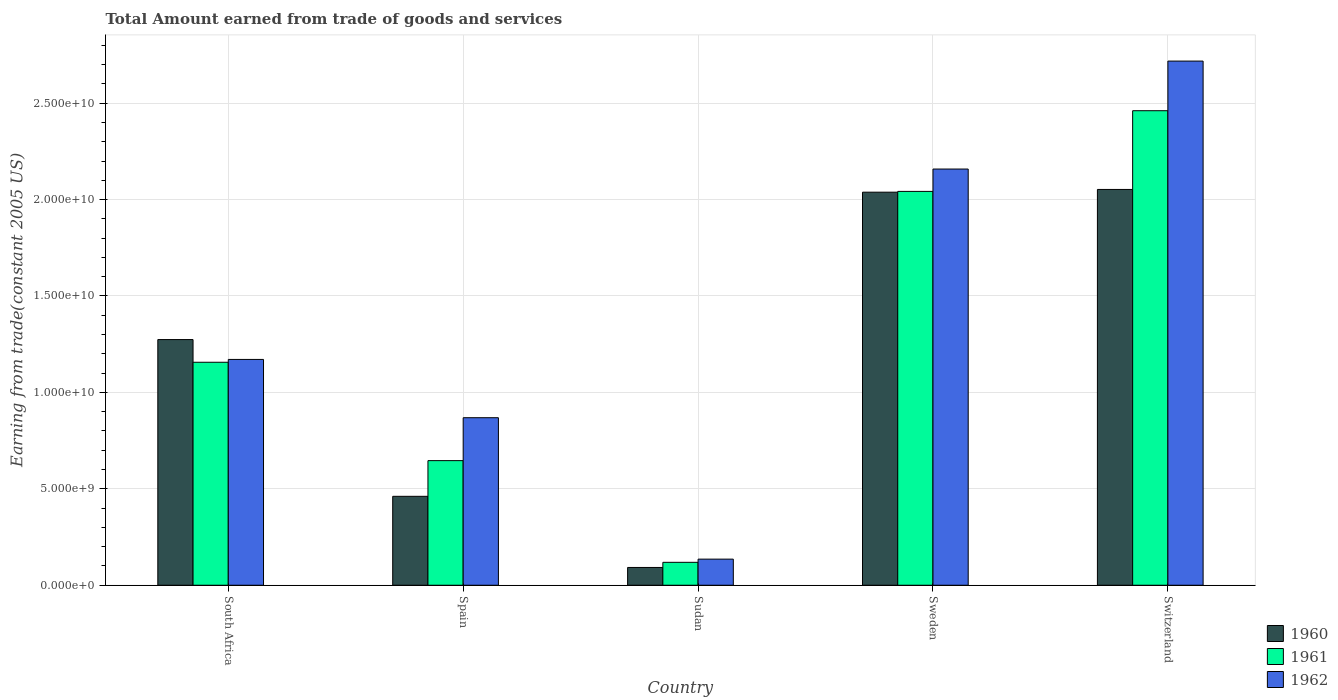How many different coloured bars are there?
Your answer should be very brief. 3. How many bars are there on the 4th tick from the left?
Give a very brief answer. 3. How many bars are there on the 3rd tick from the right?
Give a very brief answer. 3. What is the label of the 4th group of bars from the left?
Ensure brevity in your answer.  Sweden. What is the total amount earned by trading goods and services in 1962 in Sudan?
Your answer should be very brief. 1.35e+09. Across all countries, what is the maximum total amount earned by trading goods and services in 1962?
Offer a terse response. 2.72e+1. Across all countries, what is the minimum total amount earned by trading goods and services in 1961?
Keep it short and to the point. 1.19e+09. In which country was the total amount earned by trading goods and services in 1961 maximum?
Give a very brief answer. Switzerland. In which country was the total amount earned by trading goods and services in 1960 minimum?
Ensure brevity in your answer.  Sudan. What is the total total amount earned by trading goods and services in 1961 in the graph?
Give a very brief answer. 6.42e+1. What is the difference between the total amount earned by trading goods and services in 1960 in Spain and that in Sudan?
Your answer should be very brief. 3.69e+09. What is the difference between the total amount earned by trading goods and services in 1962 in Switzerland and the total amount earned by trading goods and services in 1961 in Spain?
Make the answer very short. 2.07e+1. What is the average total amount earned by trading goods and services in 1961 per country?
Provide a short and direct response. 1.28e+1. What is the difference between the total amount earned by trading goods and services of/in 1960 and total amount earned by trading goods and services of/in 1962 in Sudan?
Your response must be concise. -4.31e+08. What is the ratio of the total amount earned by trading goods and services in 1961 in Spain to that in Sweden?
Your answer should be very brief. 0.32. Is the total amount earned by trading goods and services in 1960 in South Africa less than that in Sweden?
Your response must be concise. Yes. What is the difference between the highest and the second highest total amount earned by trading goods and services in 1962?
Ensure brevity in your answer.  -5.60e+09. What is the difference between the highest and the lowest total amount earned by trading goods and services in 1961?
Your answer should be compact. 2.34e+1. In how many countries, is the total amount earned by trading goods and services in 1961 greater than the average total amount earned by trading goods and services in 1961 taken over all countries?
Ensure brevity in your answer.  2. What does the 2nd bar from the left in Spain represents?
Make the answer very short. 1961. Are all the bars in the graph horizontal?
Provide a short and direct response. No. How many legend labels are there?
Ensure brevity in your answer.  3. How are the legend labels stacked?
Offer a very short reply. Vertical. What is the title of the graph?
Provide a short and direct response. Total Amount earned from trade of goods and services. Does "1990" appear as one of the legend labels in the graph?
Give a very brief answer. No. What is the label or title of the Y-axis?
Provide a succinct answer. Earning from trade(constant 2005 US). What is the Earning from trade(constant 2005 US) in 1960 in South Africa?
Provide a short and direct response. 1.27e+1. What is the Earning from trade(constant 2005 US) in 1961 in South Africa?
Ensure brevity in your answer.  1.16e+1. What is the Earning from trade(constant 2005 US) in 1962 in South Africa?
Offer a very short reply. 1.17e+1. What is the Earning from trade(constant 2005 US) in 1960 in Spain?
Your response must be concise. 4.61e+09. What is the Earning from trade(constant 2005 US) in 1961 in Spain?
Make the answer very short. 6.46e+09. What is the Earning from trade(constant 2005 US) in 1962 in Spain?
Your answer should be very brief. 8.69e+09. What is the Earning from trade(constant 2005 US) of 1960 in Sudan?
Your answer should be very brief. 9.22e+08. What is the Earning from trade(constant 2005 US) of 1961 in Sudan?
Provide a succinct answer. 1.19e+09. What is the Earning from trade(constant 2005 US) of 1962 in Sudan?
Make the answer very short. 1.35e+09. What is the Earning from trade(constant 2005 US) in 1960 in Sweden?
Make the answer very short. 2.04e+1. What is the Earning from trade(constant 2005 US) in 1961 in Sweden?
Provide a succinct answer. 2.04e+1. What is the Earning from trade(constant 2005 US) in 1962 in Sweden?
Ensure brevity in your answer.  2.16e+1. What is the Earning from trade(constant 2005 US) in 1960 in Switzerland?
Your response must be concise. 2.05e+1. What is the Earning from trade(constant 2005 US) in 1961 in Switzerland?
Provide a short and direct response. 2.46e+1. What is the Earning from trade(constant 2005 US) of 1962 in Switzerland?
Provide a succinct answer. 2.72e+1. Across all countries, what is the maximum Earning from trade(constant 2005 US) of 1960?
Ensure brevity in your answer.  2.05e+1. Across all countries, what is the maximum Earning from trade(constant 2005 US) of 1961?
Offer a very short reply. 2.46e+1. Across all countries, what is the maximum Earning from trade(constant 2005 US) of 1962?
Your answer should be very brief. 2.72e+1. Across all countries, what is the minimum Earning from trade(constant 2005 US) of 1960?
Ensure brevity in your answer.  9.22e+08. Across all countries, what is the minimum Earning from trade(constant 2005 US) in 1961?
Provide a succinct answer. 1.19e+09. Across all countries, what is the minimum Earning from trade(constant 2005 US) in 1962?
Keep it short and to the point. 1.35e+09. What is the total Earning from trade(constant 2005 US) of 1960 in the graph?
Ensure brevity in your answer.  5.92e+1. What is the total Earning from trade(constant 2005 US) in 1961 in the graph?
Your response must be concise. 6.42e+1. What is the total Earning from trade(constant 2005 US) in 1962 in the graph?
Provide a succinct answer. 7.05e+1. What is the difference between the Earning from trade(constant 2005 US) of 1960 in South Africa and that in Spain?
Provide a succinct answer. 8.13e+09. What is the difference between the Earning from trade(constant 2005 US) of 1961 in South Africa and that in Spain?
Ensure brevity in your answer.  5.10e+09. What is the difference between the Earning from trade(constant 2005 US) in 1962 in South Africa and that in Spain?
Offer a very short reply. 3.02e+09. What is the difference between the Earning from trade(constant 2005 US) in 1960 in South Africa and that in Sudan?
Provide a short and direct response. 1.18e+1. What is the difference between the Earning from trade(constant 2005 US) in 1961 in South Africa and that in Sudan?
Your answer should be very brief. 1.04e+1. What is the difference between the Earning from trade(constant 2005 US) in 1962 in South Africa and that in Sudan?
Give a very brief answer. 1.04e+1. What is the difference between the Earning from trade(constant 2005 US) of 1960 in South Africa and that in Sweden?
Ensure brevity in your answer.  -7.64e+09. What is the difference between the Earning from trade(constant 2005 US) in 1961 in South Africa and that in Sweden?
Ensure brevity in your answer.  -8.86e+09. What is the difference between the Earning from trade(constant 2005 US) in 1962 in South Africa and that in Sweden?
Offer a very short reply. -9.87e+09. What is the difference between the Earning from trade(constant 2005 US) of 1960 in South Africa and that in Switzerland?
Give a very brief answer. -7.79e+09. What is the difference between the Earning from trade(constant 2005 US) of 1961 in South Africa and that in Switzerland?
Your response must be concise. -1.30e+1. What is the difference between the Earning from trade(constant 2005 US) of 1962 in South Africa and that in Switzerland?
Keep it short and to the point. -1.55e+1. What is the difference between the Earning from trade(constant 2005 US) of 1960 in Spain and that in Sudan?
Ensure brevity in your answer.  3.69e+09. What is the difference between the Earning from trade(constant 2005 US) of 1961 in Spain and that in Sudan?
Keep it short and to the point. 5.27e+09. What is the difference between the Earning from trade(constant 2005 US) of 1962 in Spain and that in Sudan?
Provide a succinct answer. 7.33e+09. What is the difference between the Earning from trade(constant 2005 US) in 1960 in Spain and that in Sweden?
Give a very brief answer. -1.58e+1. What is the difference between the Earning from trade(constant 2005 US) in 1961 in Spain and that in Sweden?
Offer a terse response. -1.40e+1. What is the difference between the Earning from trade(constant 2005 US) in 1962 in Spain and that in Sweden?
Your response must be concise. -1.29e+1. What is the difference between the Earning from trade(constant 2005 US) of 1960 in Spain and that in Switzerland?
Give a very brief answer. -1.59e+1. What is the difference between the Earning from trade(constant 2005 US) in 1961 in Spain and that in Switzerland?
Ensure brevity in your answer.  -1.81e+1. What is the difference between the Earning from trade(constant 2005 US) in 1962 in Spain and that in Switzerland?
Offer a terse response. -1.85e+1. What is the difference between the Earning from trade(constant 2005 US) in 1960 in Sudan and that in Sweden?
Your answer should be compact. -1.95e+1. What is the difference between the Earning from trade(constant 2005 US) in 1961 in Sudan and that in Sweden?
Your answer should be very brief. -1.92e+1. What is the difference between the Earning from trade(constant 2005 US) of 1962 in Sudan and that in Sweden?
Offer a very short reply. -2.02e+1. What is the difference between the Earning from trade(constant 2005 US) in 1960 in Sudan and that in Switzerland?
Offer a terse response. -1.96e+1. What is the difference between the Earning from trade(constant 2005 US) of 1961 in Sudan and that in Switzerland?
Give a very brief answer. -2.34e+1. What is the difference between the Earning from trade(constant 2005 US) in 1962 in Sudan and that in Switzerland?
Ensure brevity in your answer.  -2.58e+1. What is the difference between the Earning from trade(constant 2005 US) in 1960 in Sweden and that in Switzerland?
Provide a short and direct response. -1.42e+08. What is the difference between the Earning from trade(constant 2005 US) of 1961 in Sweden and that in Switzerland?
Your response must be concise. -4.18e+09. What is the difference between the Earning from trade(constant 2005 US) in 1962 in Sweden and that in Switzerland?
Ensure brevity in your answer.  -5.60e+09. What is the difference between the Earning from trade(constant 2005 US) of 1960 in South Africa and the Earning from trade(constant 2005 US) of 1961 in Spain?
Your answer should be compact. 6.28e+09. What is the difference between the Earning from trade(constant 2005 US) in 1960 in South Africa and the Earning from trade(constant 2005 US) in 1962 in Spain?
Give a very brief answer. 4.05e+09. What is the difference between the Earning from trade(constant 2005 US) in 1961 in South Africa and the Earning from trade(constant 2005 US) in 1962 in Spain?
Provide a succinct answer. 2.88e+09. What is the difference between the Earning from trade(constant 2005 US) in 1960 in South Africa and the Earning from trade(constant 2005 US) in 1961 in Sudan?
Offer a very short reply. 1.16e+1. What is the difference between the Earning from trade(constant 2005 US) of 1960 in South Africa and the Earning from trade(constant 2005 US) of 1962 in Sudan?
Offer a very short reply. 1.14e+1. What is the difference between the Earning from trade(constant 2005 US) of 1961 in South Africa and the Earning from trade(constant 2005 US) of 1962 in Sudan?
Provide a succinct answer. 1.02e+1. What is the difference between the Earning from trade(constant 2005 US) in 1960 in South Africa and the Earning from trade(constant 2005 US) in 1961 in Sweden?
Your response must be concise. -7.68e+09. What is the difference between the Earning from trade(constant 2005 US) in 1960 in South Africa and the Earning from trade(constant 2005 US) in 1962 in Sweden?
Give a very brief answer. -8.84e+09. What is the difference between the Earning from trade(constant 2005 US) of 1961 in South Africa and the Earning from trade(constant 2005 US) of 1962 in Sweden?
Ensure brevity in your answer.  -1.00e+1. What is the difference between the Earning from trade(constant 2005 US) in 1960 in South Africa and the Earning from trade(constant 2005 US) in 1961 in Switzerland?
Give a very brief answer. -1.19e+1. What is the difference between the Earning from trade(constant 2005 US) in 1960 in South Africa and the Earning from trade(constant 2005 US) in 1962 in Switzerland?
Provide a short and direct response. -1.44e+1. What is the difference between the Earning from trade(constant 2005 US) in 1961 in South Africa and the Earning from trade(constant 2005 US) in 1962 in Switzerland?
Provide a short and direct response. -1.56e+1. What is the difference between the Earning from trade(constant 2005 US) in 1960 in Spain and the Earning from trade(constant 2005 US) in 1961 in Sudan?
Your answer should be compact. 3.42e+09. What is the difference between the Earning from trade(constant 2005 US) in 1960 in Spain and the Earning from trade(constant 2005 US) in 1962 in Sudan?
Offer a terse response. 3.26e+09. What is the difference between the Earning from trade(constant 2005 US) of 1961 in Spain and the Earning from trade(constant 2005 US) of 1962 in Sudan?
Provide a short and direct response. 5.11e+09. What is the difference between the Earning from trade(constant 2005 US) of 1960 in Spain and the Earning from trade(constant 2005 US) of 1961 in Sweden?
Your answer should be very brief. -1.58e+1. What is the difference between the Earning from trade(constant 2005 US) of 1960 in Spain and the Earning from trade(constant 2005 US) of 1962 in Sweden?
Provide a succinct answer. -1.70e+1. What is the difference between the Earning from trade(constant 2005 US) of 1961 in Spain and the Earning from trade(constant 2005 US) of 1962 in Sweden?
Give a very brief answer. -1.51e+1. What is the difference between the Earning from trade(constant 2005 US) of 1960 in Spain and the Earning from trade(constant 2005 US) of 1961 in Switzerland?
Ensure brevity in your answer.  -2.00e+1. What is the difference between the Earning from trade(constant 2005 US) of 1960 in Spain and the Earning from trade(constant 2005 US) of 1962 in Switzerland?
Your response must be concise. -2.26e+1. What is the difference between the Earning from trade(constant 2005 US) of 1961 in Spain and the Earning from trade(constant 2005 US) of 1962 in Switzerland?
Provide a succinct answer. -2.07e+1. What is the difference between the Earning from trade(constant 2005 US) of 1960 in Sudan and the Earning from trade(constant 2005 US) of 1961 in Sweden?
Keep it short and to the point. -1.95e+1. What is the difference between the Earning from trade(constant 2005 US) of 1960 in Sudan and the Earning from trade(constant 2005 US) of 1962 in Sweden?
Your answer should be compact. -2.07e+1. What is the difference between the Earning from trade(constant 2005 US) in 1961 in Sudan and the Earning from trade(constant 2005 US) in 1962 in Sweden?
Keep it short and to the point. -2.04e+1. What is the difference between the Earning from trade(constant 2005 US) in 1960 in Sudan and the Earning from trade(constant 2005 US) in 1961 in Switzerland?
Ensure brevity in your answer.  -2.37e+1. What is the difference between the Earning from trade(constant 2005 US) in 1960 in Sudan and the Earning from trade(constant 2005 US) in 1962 in Switzerland?
Give a very brief answer. -2.63e+1. What is the difference between the Earning from trade(constant 2005 US) in 1961 in Sudan and the Earning from trade(constant 2005 US) in 1962 in Switzerland?
Ensure brevity in your answer.  -2.60e+1. What is the difference between the Earning from trade(constant 2005 US) in 1960 in Sweden and the Earning from trade(constant 2005 US) in 1961 in Switzerland?
Keep it short and to the point. -4.22e+09. What is the difference between the Earning from trade(constant 2005 US) in 1960 in Sweden and the Earning from trade(constant 2005 US) in 1962 in Switzerland?
Keep it short and to the point. -6.80e+09. What is the difference between the Earning from trade(constant 2005 US) in 1961 in Sweden and the Earning from trade(constant 2005 US) in 1962 in Switzerland?
Provide a short and direct response. -6.76e+09. What is the average Earning from trade(constant 2005 US) in 1960 per country?
Ensure brevity in your answer.  1.18e+1. What is the average Earning from trade(constant 2005 US) of 1961 per country?
Your response must be concise. 1.28e+1. What is the average Earning from trade(constant 2005 US) in 1962 per country?
Offer a terse response. 1.41e+1. What is the difference between the Earning from trade(constant 2005 US) of 1960 and Earning from trade(constant 2005 US) of 1961 in South Africa?
Provide a short and direct response. 1.18e+09. What is the difference between the Earning from trade(constant 2005 US) in 1960 and Earning from trade(constant 2005 US) in 1962 in South Africa?
Make the answer very short. 1.03e+09. What is the difference between the Earning from trade(constant 2005 US) of 1961 and Earning from trade(constant 2005 US) of 1962 in South Africa?
Your answer should be compact. -1.46e+08. What is the difference between the Earning from trade(constant 2005 US) of 1960 and Earning from trade(constant 2005 US) of 1961 in Spain?
Your response must be concise. -1.85e+09. What is the difference between the Earning from trade(constant 2005 US) in 1960 and Earning from trade(constant 2005 US) in 1962 in Spain?
Ensure brevity in your answer.  -4.08e+09. What is the difference between the Earning from trade(constant 2005 US) in 1961 and Earning from trade(constant 2005 US) in 1962 in Spain?
Keep it short and to the point. -2.23e+09. What is the difference between the Earning from trade(constant 2005 US) in 1960 and Earning from trade(constant 2005 US) in 1961 in Sudan?
Your answer should be very brief. -2.66e+08. What is the difference between the Earning from trade(constant 2005 US) in 1960 and Earning from trade(constant 2005 US) in 1962 in Sudan?
Make the answer very short. -4.31e+08. What is the difference between the Earning from trade(constant 2005 US) of 1961 and Earning from trade(constant 2005 US) of 1962 in Sudan?
Keep it short and to the point. -1.65e+08. What is the difference between the Earning from trade(constant 2005 US) in 1960 and Earning from trade(constant 2005 US) in 1961 in Sweden?
Provide a succinct answer. -4.05e+07. What is the difference between the Earning from trade(constant 2005 US) in 1960 and Earning from trade(constant 2005 US) in 1962 in Sweden?
Make the answer very short. -1.20e+09. What is the difference between the Earning from trade(constant 2005 US) of 1961 and Earning from trade(constant 2005 US) of 1962 in Sweden?
Provide a succinct answer. -1.16e+09. What is the difference between the Earning from trade(constant 2005 US) in 1960 and Earning from trade(constant 2005 US) in 1961 in Switzerland?
Provide a succinct answer. -4.08e+09. What is the difference between the Earning from trade(constant 2005 US) of 1960 and Earning from trade(constant 2005 US) of 1962 in Switzerland?
Provide a short and direct response. -6.66e+09. What is the difference between the Earning from trade(constant 2005 US) in 1961 and Earning from trade(constant 2005 US) in 1962 in Switzerland?
Provide a succinct answer. -2.57e+09. What is the ratio of the Earning from trade(constant 2005 US) of 1960 in South Africa to that in Spain?
Provide a short and direct response. 2.76. What is the ratio of the Earning from trade(constant 2005 US) in 1961 in South Africa to that in Spain?
Your response must be concise. 1.79. What is the ratio of the Earning from trade(constant 2005 US) of 1962 in South Africa to that in Spain?
Your response must be concise. 1.35. What is the ratio of the Earning from trade(constant 2005 US) in 1960 in South Africa to that in Sudan?
Give a very brief answer. 13.82. What is the ratio of the Earning from trade(constant 2005 US) in 1961 in South Africa to that in Sudan?
Give a very brief answer. 9.73. What is the ratio of the Earning from trade(constant 2005 US) in 1962 in South Africa to that in Sudan?
Ensure brevity in your answer.  8.65. What is the ratio of the Earning from trade(constant 2005 US) in 1960 in South Africa to that in Sweden?
Your answer should be compact. 0.62. What is the ratio of the Earning from trade(constant 2005 US) of 1961 in South Africa to that in Sweden?
Provide a short and direct response. 0.57. What is the ratio of the Earning from trade(constant 2005 US) in 1962 in South Africa to that in Sweden?
Give a very brief answer. 0.54. What is the ratio of the Earning from trade(constant 2005 US) of 1960 in South Africa to that in Switzerland?
Your response must be concise. 0.62. What is the ratio of the Earning from trade(constant 2005 US) in 1961 in South Africa to that in Switzerland?
Keep it short and to the point. 0.47. What is the ratio of the Earning from trade(constant 2005 US) of 1962 in South Africa to that in Switzerland?
Ensure brevity in your answer.  0.43. What is the ratio of the Earning from trade(constant 2005 US) of 1960 in Spain to that in Sudan?
Your answer should be compact. 5. What is the ratio of the Earning from trade(constant 2005 US) of 1961 in Spain to that in Sudan?
Offer a very short reply. 5.44. What is the ratio of the Earning from trade(constant 2005 US) of 1962 in Spain to that in Sudan?
Provide a succinct answer. 6.42. What is the ratio of the Earning from trade(constant 2005 US) in 1960 in Spain to that in Sweden?
Ensure brevity in your answer.  0.23. What is the ratio of the Earning from trade(constant 2005 US) in 1961 in Spain to that in Sweden?
Provide a short and direct response. 0.32. What is the ratio of the Earning from trade(constant 2005 US) of 1962 in Spain to that in Sweden?
Give a very brief answer. 0.4. What is the ratio of the Earning from trade(constant 2005 US) in 1960 in Spain to that in Switzerland?
Ensure brevity in your answer.  0.22. What is the ratio of the Earning from trade(constant 2005 US) of 1961 in Spain to that in Switzerland?
Ensure brevity in your answer.  0.26. What is the ratio of the Earning from trade(constant 2005 US) of 1962 in Spain to that in Switzerland?
Your response must be concise. 0.32. What is the ratio of the Earning from trade(constant 2005 US) in 1960 in Sudan to that in Sweden?
Offer a very short reply. 0.05. What is the ratio of the Earning from trade(constant 2005 US) in 1961 in Sudan to that in Sweden?
Ensure brevity in your answer.  0.06. What is the ratio of the Earning from trade(constant 2005 US) of 1962 in Sudan to that in Sweden?
Your answer should be very brief. 0.06. What is the ratio of the Earning from trade(constant 2005 US) in 1960 in Sudan to that in Switzerland?
Ensure brevity in your answer.  0.04. What is the ratio of the Earning from trade(constant 2005 US) in 1961 in Sudan to that in Switzerland?
Ensure brevity in your answer.  0.05. What is the ratio of the Earning from trade(constant 2005 US) in 1962 in Sudan to that in Switzerland?
Your answer should be very brief. 0.05. What is the ratio of the Earning from trade(constant 2005 US) in 1960 in Sweden to that in Switzerland?
Your answer should be compact. 0.99. What is the ratio of the Earning from trade(constant 2005 US) of 1961 in Sweden to that in Switzerland?
Provide a succinct answer. 0.83. What is the ratio of the Earning from trade(constant 2005 US) in 1962 in Sweden to that in Switzerland?
Your answer should be compact. 0.79. What is the difference between the highest and the second highest Earning from trade(constant 2005 US) of 1960?
Give a very brief answer. 1.42e+08. What is the difference between the highest and the second highest Earning from trade(constant 2005 US) in 1961?
Your answer should be compact. 4.18e+09. What is the difference between the highest and the second highest Earning from trade(constant 2005 US) of 1962?
Provide a short and direct response. 5.60e+09. What is the difference between the highest and the lowest Earning from trade(constant 2005 US) in 1960?
Ensure brevity in your answer.  1.96e+1. What is the difference between the highest and the lowest Earning from trade(constant 2005 US) in 1961?
Provide a short and direct response. 2.34e+1. What is the difference between the highest and the lowest Earning from trade(constant 2005 US) of 1962?
Provide a short and direct response. 2.58e+1. 